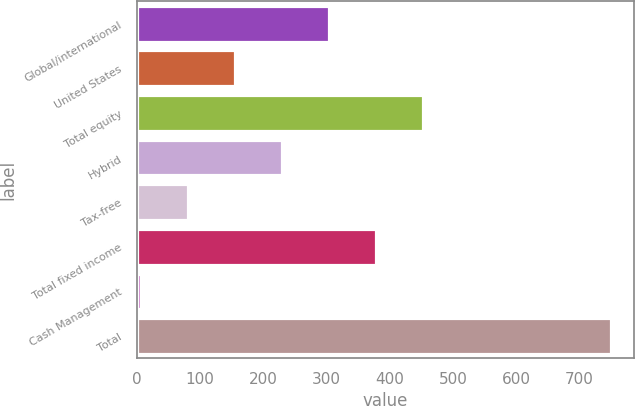<chart> <loc_0><loc_0><loc_500><loc_500><bar_chart><fcel>Global/international<fcel>United States<fcel>Total equity<fcel>Hybrid<fcel>Tax-free<fcel>Total fixed income<fcel>Cash Management<fcel>Total<nl><fcel>303.62<fcel>155.06<fcel>452.18<fcel>229.34<fcel>80.78<fcel>377.9<fcel>6.5<fcel>749.3<nl></chart> 